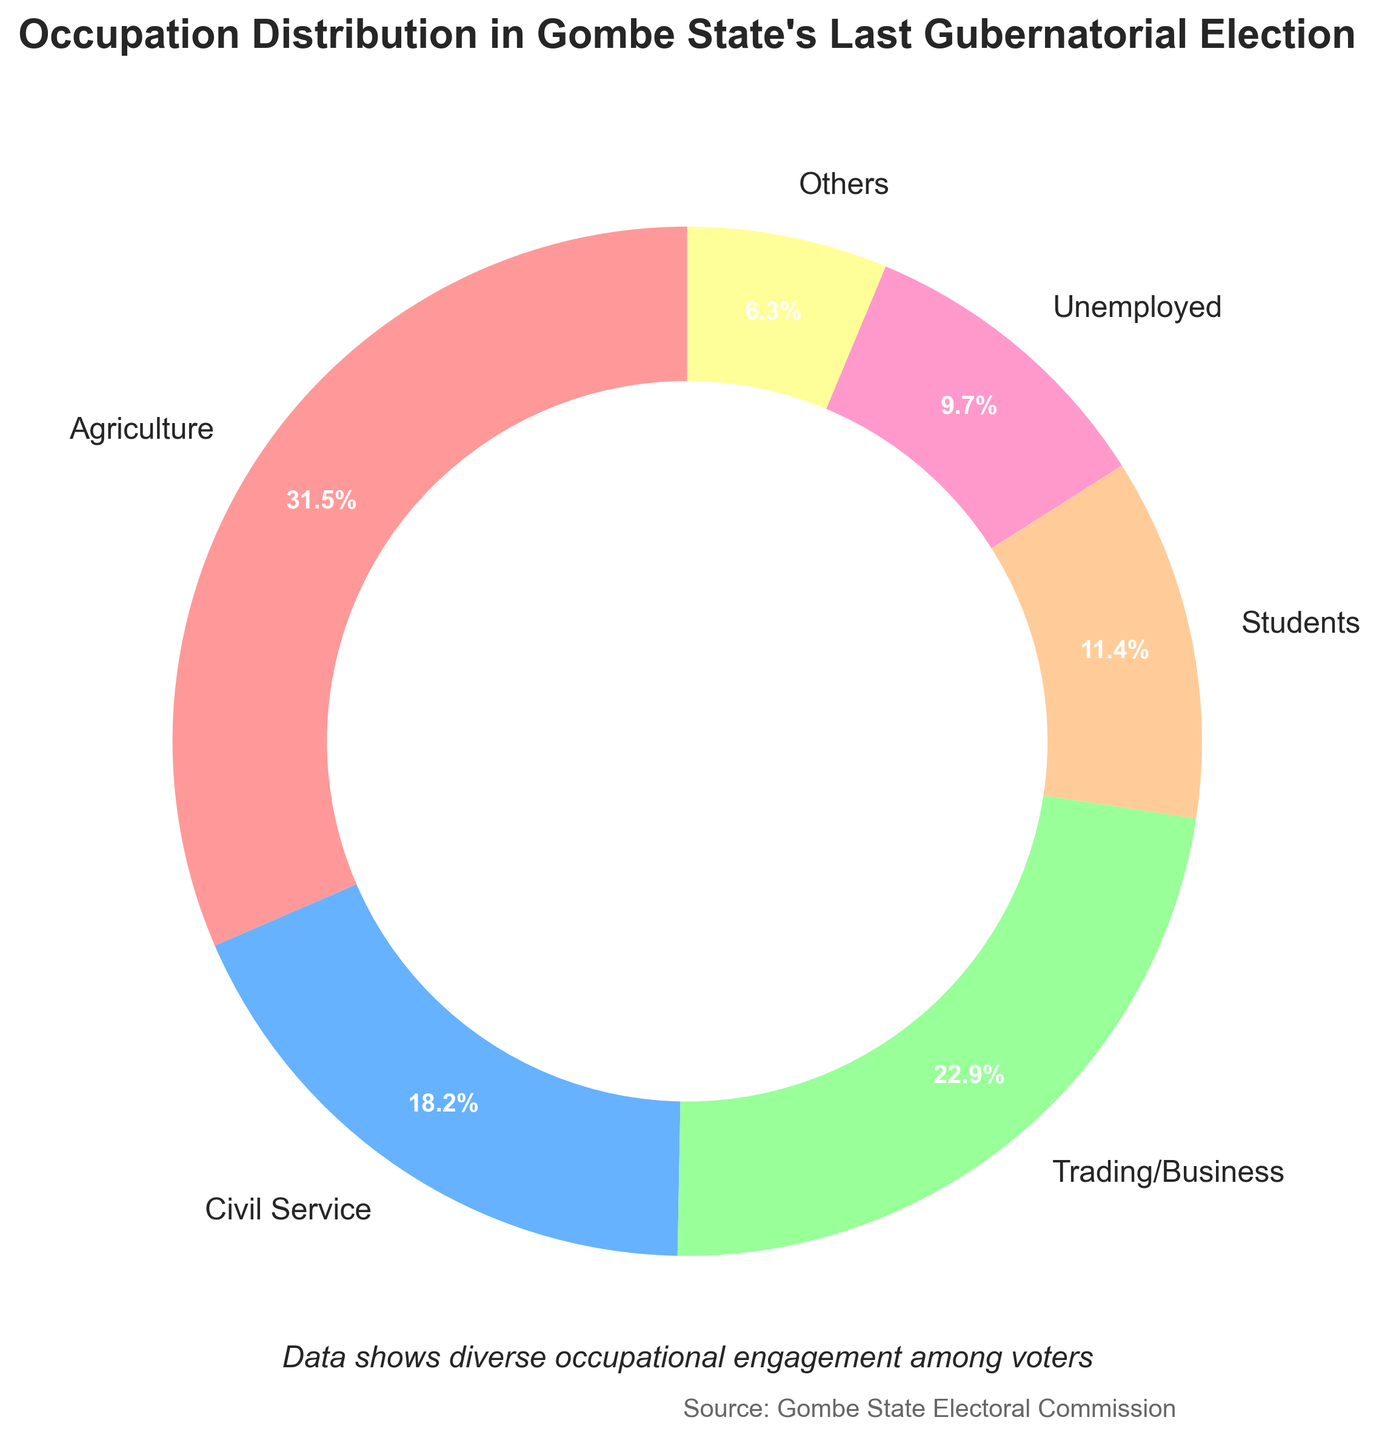What is the most common occupation among voters based on the pie chart? By looking at the figure, the largest wedge corresponds to Agriculture, indicating it's the most common occupation among voters.
Answer: Agriculture Which occupation has the least percentage of voters? The smallest wedge is labeled as "Others," indicating it has the least percentage among the occupational categories.
Answer: Others What is the approximate percentage difference between voters involved in Civil Service and those in Trading/Business? Trading/Business is 22.9% and Civil Service is 18.2%. The difference is 22.9% - 18.2% = 4.7%.
Answer: 4.7% Are there more voters involved in Agriculture or the combined total of Students and Unemployed? Agriculture has 31.5%. Students and Unemployed combined have 11.4% + 9.7% = 21.1%, which is less than 31.5%.
Answer: Agriculture Which two occupations combined make up roughly the same percentage as Agriculture? Civil Service (18.2%) and Students (11.4%) combined are 18.2% + 11.4% = 29.6%, which is closest to Agriculture's 31.5%.
Answer: Civil Service and Students What are the two largest occupational groups? The two largest wedges are Agriculture and Trading/Business.
Answer: Agriculture and Trading/Business What is the approximate percentage of voters not involved in Agriculture, Civil Service, or Trading/Business? Agriculture is 31.5%, Civil Service is 18.2%, Trading/Business is 22.9%. Combined, that's 31.5% + 18.2% + 22.9% = 72.6%. So, 100% - 72.6% = 27.4%.
Answer: 27.4% What appears to be the dominant color in the pie chart for the occupation with the highest percentage? The largest segment, Agriculture, appears to be predominantly red.
Answer: Red How does the percentage of voters in Civil Service compare to those categorized as Students? Civil Service has 18.2% and Students have 11.4%, indicating that Civil Service has a higher percentage.
Answer: Civil Service If another occupation category of 5% were added, how would the total percentage change for all categories? Current total is 100%. Adding another 5% would make it 105%, which exceeds the 100% limit, indicating a possible error.
Answer: 105% (error) 